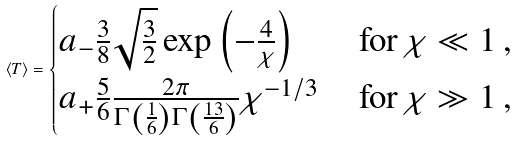<formula> <loc_0><loc_0><loc_500><loc_500>\langle T \rangle = \begin{cases} a _ { - } \frac { 3 } { 8 } \sqrt { \frac { 3 } { 2 } } \exp \left ( - \frac { 4 } { \chi } \right ) \, & \text {for} \, \chi \ll 1 \, , \\ a _ { + } \frac { 5 } { 6 } \frac { 2 \pi } { \Gamma \left ( \frac { 1 } { 6 } \right ) \Gamma \left ( \frac { 1 3 } { 6 } \right ) } \chi ^ { - 1 / 3 } \, & \text {for} \, \chi \gg 1 \, , \end{cases}</formula> 